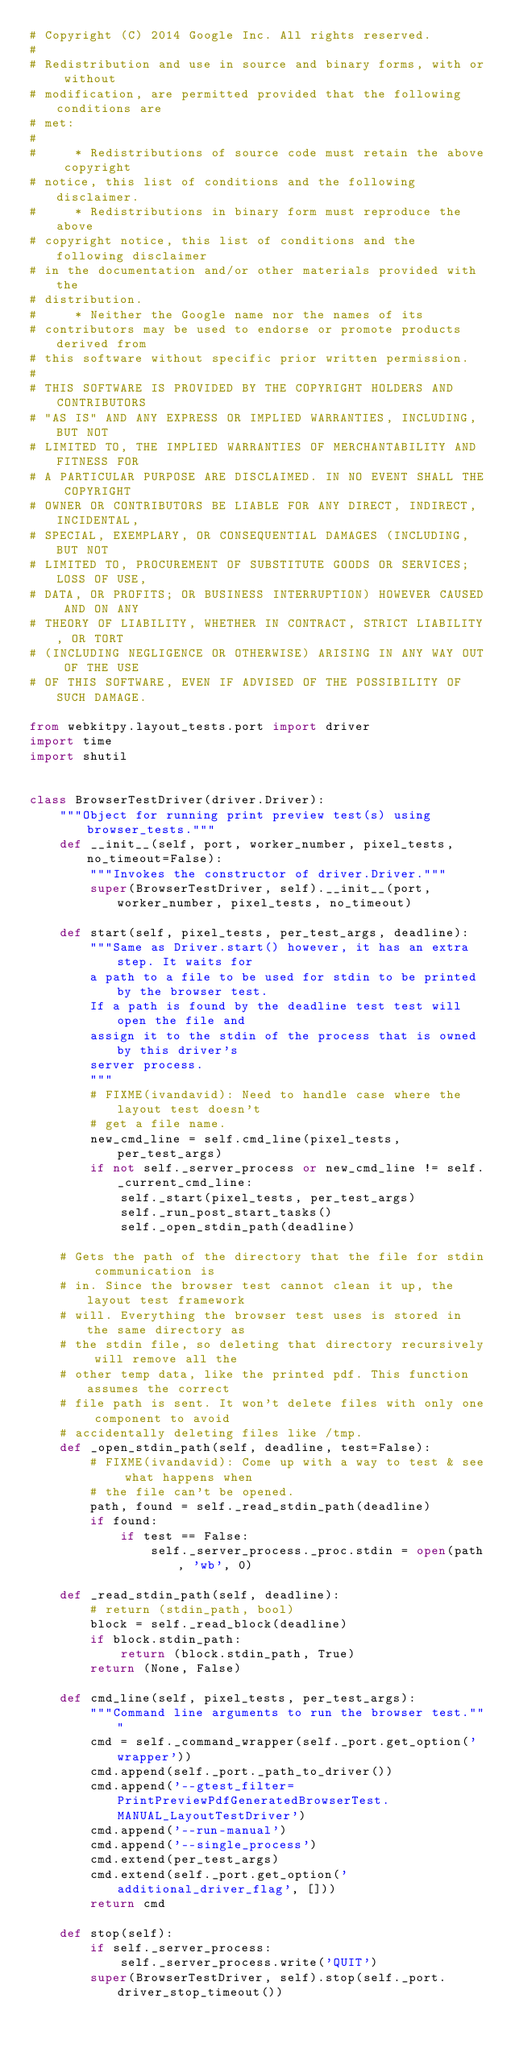<code> <loc_0><loc_0><loc_500><loc_500><_Python_># Copyright (C) 2014 Google Inc. All rights reserved.
#
# Redistribution and use in source and binary forms, with or without
# modification, are permitted provided that the following conditions are
# met:
#
#     * Redistributions of source code must retain the above copyright
# notice, this list of conditions and the following disclaimer.
#     * Redistributions in binary form must reproduce the above
# copyright notice, this list of conditions and the following disclaimer
# in the documentation and/or other materials provided with the
# distribution.
#     * Neither the Google name nor the names of its
# contributors may be used to endorse or promote products derived from
# this software without specific prior written permission.
#
# THIS SOFTWARE IS PROVIDED BY THE COPYRIGHT HOLDERS AND CONTRIBUTORS
# "AS IS" AND ANY EXPRESS OR IMPLIED WARRANTIES, INCLUDING, BUT NOT
# LIMITED TO, THE IMPLIED WARRANTIES OF MERCHANTABILITY AND FITNESS FOR
# A PARTICULAR PURPOSE ARE DISCLAIMED. IN NO EVENT SHALL THE COPYRIGHT
# OWNER OR CONTRIBUTORS BE LIABLE FOR ANY DIRECT, INDIRECT, INCIDENTAL,
# SPECIAL, EXEMPLARY, OR CONSEQUENTIAL DAMAGES (INCLUDING, BUT NOT
# LIMITED TO, PROCUREMENT OF SUBSTITUTE GOODS OR SERVICES; LOSS OF USE,
# DATA, OR PROFITS; OR BUSINESS INTERRUPTION) HOWEVER CAUSED AND ON ANY
# THEORY OF LIABILITY, WHETHER IN CONTRACT, STRICT LIABILITY, OR TORT
# (INCLUDING NEGLIGENCE OR OTHERWISE) ARISING IN ANY WAY OUT OF THE USE
# OF THIS SOFTWARE, EVEN IF ADVISED OF THE POSSIBILITY OF SUCH DAMAGE.

from webkitpy.layout_tests.port import driver
import time
import shutil


class BrowserTestDriver(driver.Driver):
    """Object for running print preview test(s) using browser_tests."""
    def __init__(self, port, worker_number, pixel_tests, no_timeout=False):
        """Invokes the constructor of driver.Driver."""
        super(BrowserTestDriver, self).__init__(port, worker_number, pixel_tests, no_timeout)

    def start(self, pixel_tests, per_test_args, deadline):
        """Same as Driver.start() however, it has an extra step. It waits for
        a path to a file to be used for stdin to be printed by the browser test.
        If a path is found by the deadline test test will open the file and
        assign it to the stdin of the process that is owned by this driver's
        server process.
        """
        # FIXME(ivandavid): Need to handle case where the layout test doesn't
        # get a file name.
        new_cmd_line = self.cmd_line(pixel_tests, per_test_args)
        if not self._server_process or new_cmd_line != self._current_cmd_line:
            self._start(pixel_tests, per_test_args)
            self._run_post_start_tasks()
            self._open_stdin_path(deadline)

    # Gets the path of the directory that the file for stdin communication is
    # in. Since the browser test cannot clean it up, the layout test framework
    # will. Everything the browser test uses is stored in the same directory as
    # the stdin file, so deleting that directory recursively will remove all the
    # other temp data, like the printed pdf. This function assumes the correct
    # file path is sent. It won't delete files with only one component to avoid
    # accidentally deleting files like /tmp.
    def _open_stdin_path(self, deadline, test=False):
        # FIXME(ivandavid): Come up with a way to test & see what happens when
        # the file can't be opened.
        path, found = self._read_stdin_path(deadline)
        if found:
            if test == False:
                self._server_process._proc.stdin = open(path, 'wb', 0)

    def _read_stdin_path(self, deadline):
        # return (stdin_path, bool)
        block = self._read_block(deadline)
        if block.stdin_path:
            return (block.stdin_path, True)
        return (None, False)

    def cmd_line(self, pixel_tests, per_test_args):
        """Command line arguments to run the browser test."""
        cmd = self._command_wrapper(self._port.get_option('wrapper'))
        cmd.append(self._port._path_to_driver())
        cmd.append('--gtest_filter=PrintPreviewPdfGeneratedBrowserTest.MANUAL_LayoutTestDriver')
        cmd.append('--run-manual')
        cmd.append('--single_process')
        cmd.extend(per_test_args)
        cmd.extend(self._port.get_option('additional_driver_flag', []))
        return cmd

    def stop(self):
        if self._server_process:
            self._server_process.write('QUIT')
        super(BrowserTestDriver, self).stop(self._port.driver_stop_timeout())
</code> 